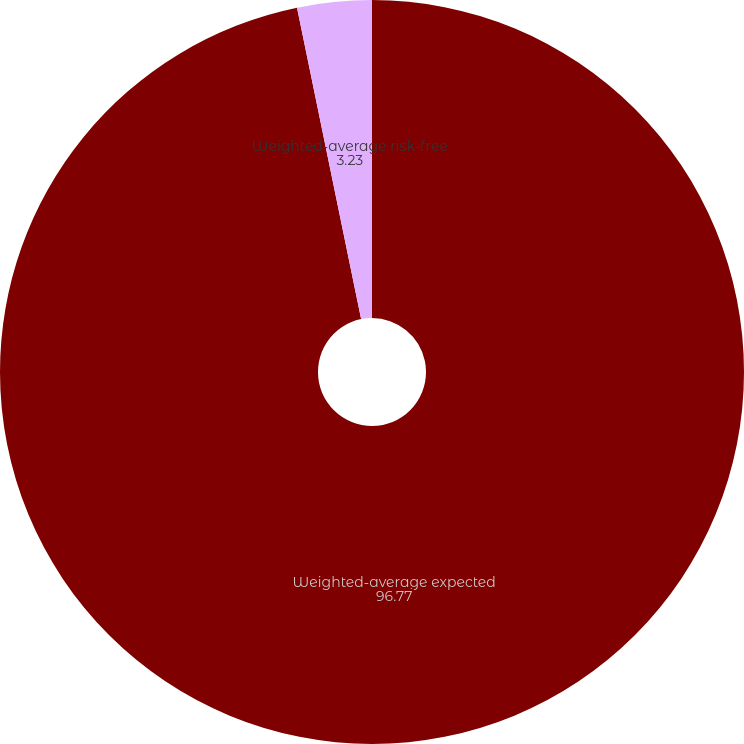Convert chart. <chart><loc_0><loc_0><loc_500><loc_500><pie_chart><fcel>Weighted-average expected<fcel>Weighted-average risk-free<nl><fcel>96.77%<fcel>3.23%<nl></chart> 